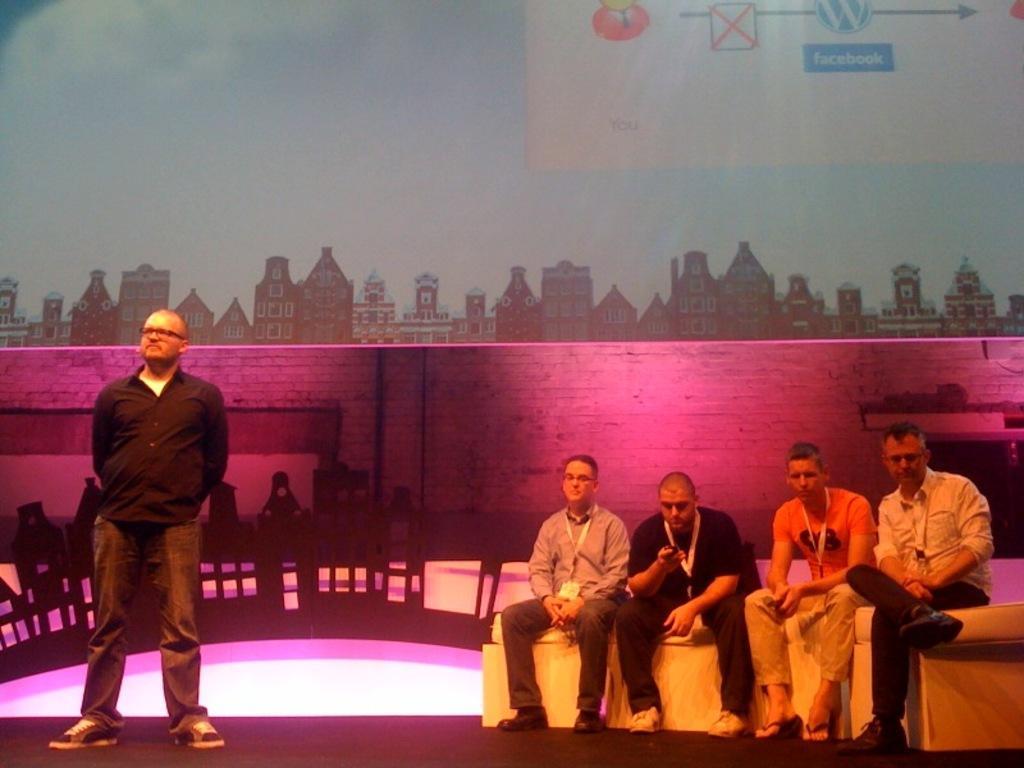Could you give a brief overview of what you see in this image? In this image I can see few people are sitting on the couch and one person is standing. Back I can see a wall and banner. I can see the pink and yellow color lighting. 